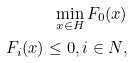<formula> <loc_0><loc_0><loc_500><loc_500>\min _ { x \in H } F _ { 0 } ( x ) \\ F _ { i } ( x ) \leq 0 , i \in N ,</formula> 